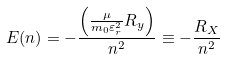<formula> <loc_0><loc_0><loc_500><loc_500>E ( n ) = - { \frac { \left ( { \frac { \mu } { m _ { 0 } \varepsilon _ { r } ^ { 2 } } } R _ { y } \right ) } { n ^ { 2 } } } \equiv - { \frac { R _ { X } } { n ^ { 2 } } }</formula> 